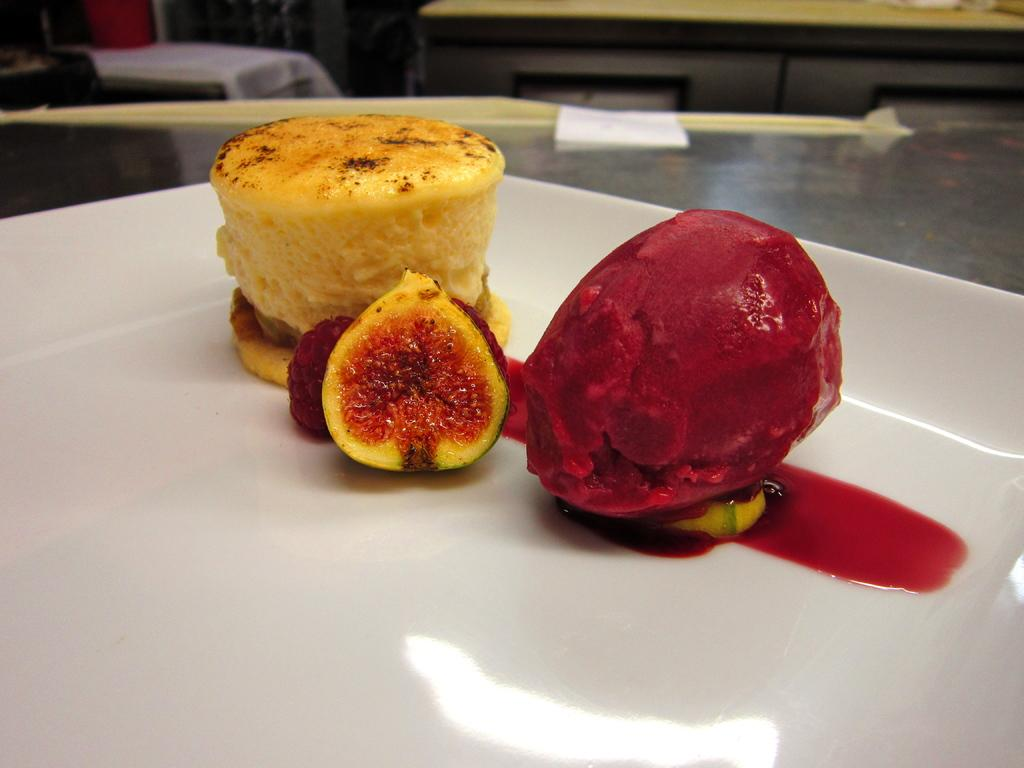What is the main subject of the image? There is a food item in the image. How is the food item presented? The food item is in a plate. What other types of food can be seen in the image? There are fruits in the image. Where is the plate with the food item located? The plate is placed on a surface. Can you tell me how many rabbits are driving cars in the image? There are no rabbits or cars present in the image. 